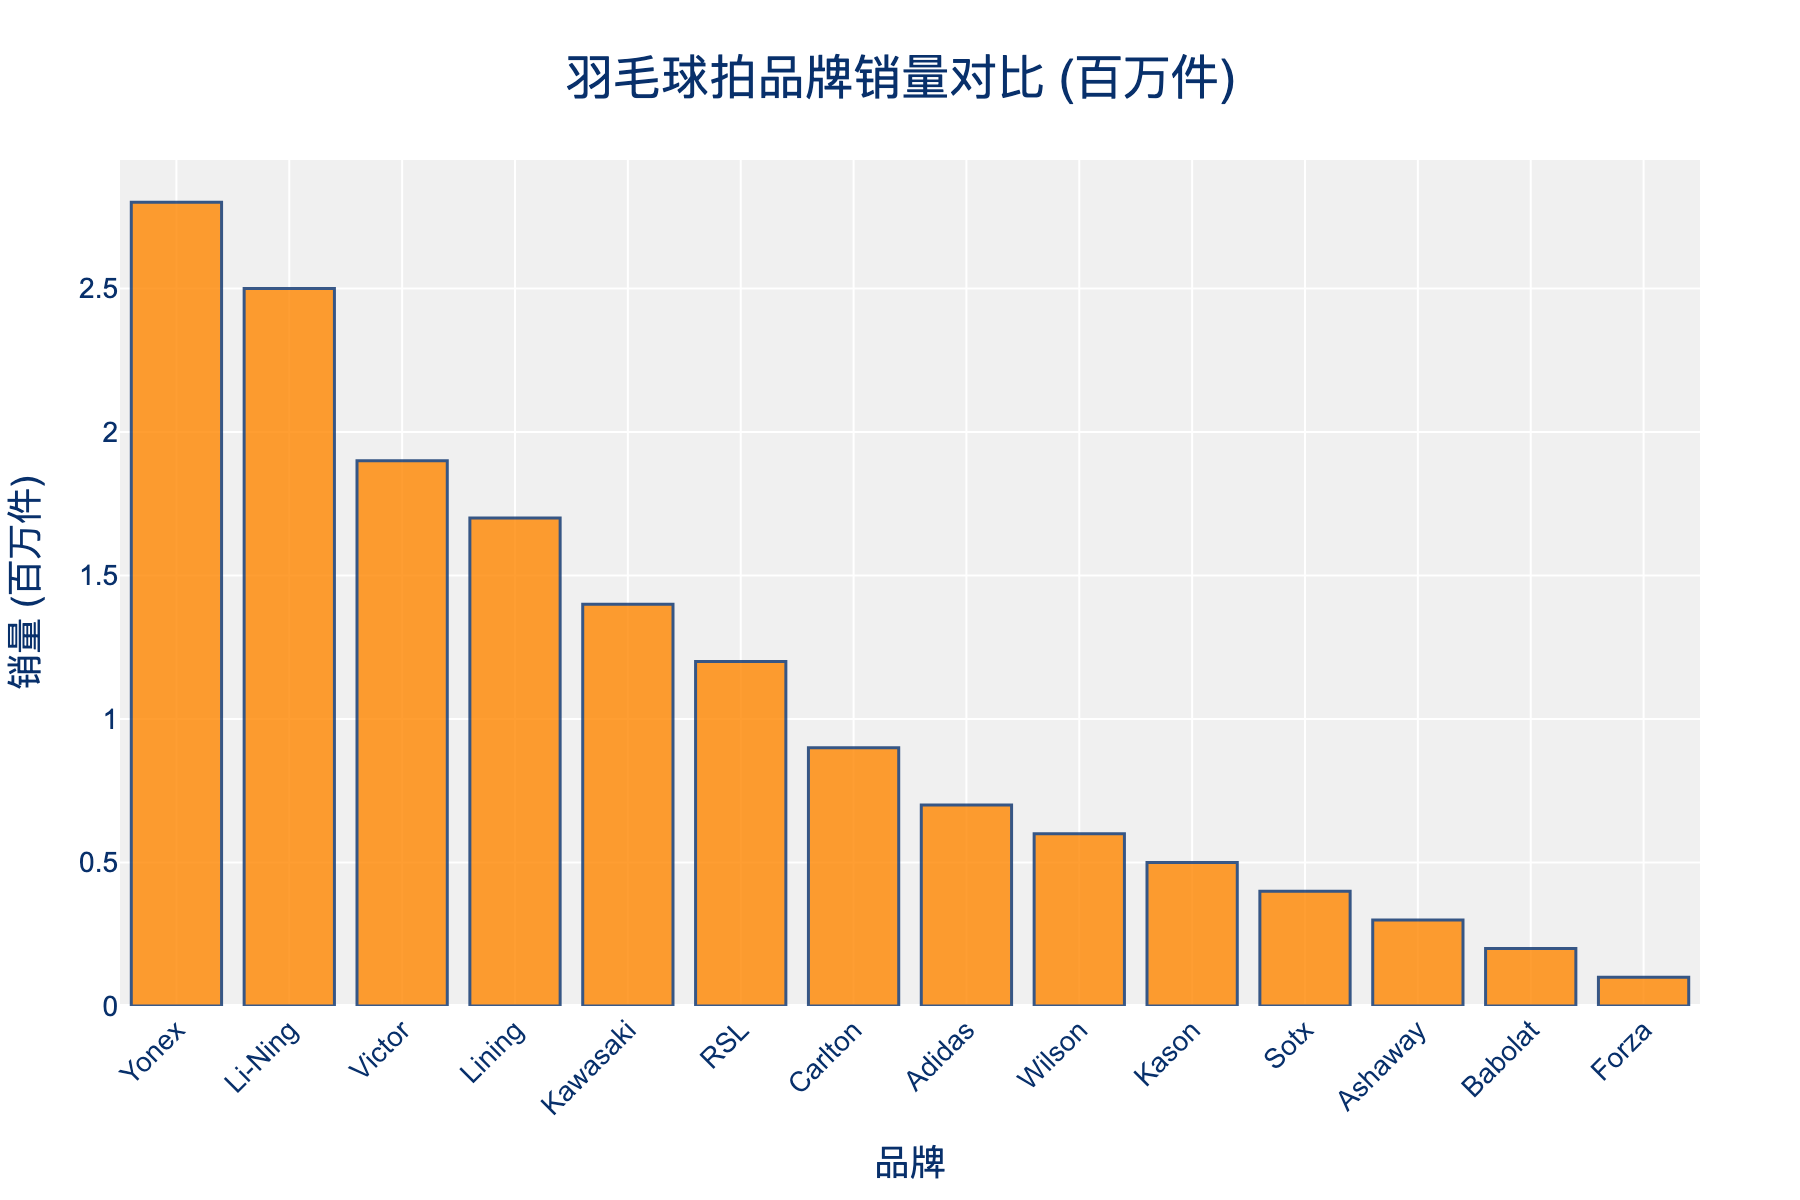Which brand has the highest badminton racket sales? The bar chart shows the highest bar belonging to the Yonex brand which indicates that Yonex has the highest sales.
Answer: Yonex Which are the top three brands in terms of sales? The three tallest bars in the chart are for the brands Yonex, Li-Ning, and Victor, representing the top three brands in terms of sales.
Answer: Yonex, Li-Ning, Victor How much more does Yonex sell compared to Wilson? According to the chart, Yonex sells 2.8 million units and Wilson sells 0.6 million units. Subtracting Wilson's sales from Yonex's sales: 2.8 - 0.6 = 2.2 million units.
Answer: 2.2 million units What is the combined sales volume of Kason, Sotx, Ashaway, and Babolat? Add the sales values for the four brands: Kason (0.5) + Sotx (0.4) + Ashaway (0.3) + Babolat (0.2) = 1.4 million units.
Answer: 1.4 million units What is the average sales among the top five brands? The top five brands by sales are Yonex (2.8), Li-Ning (2.5), Victor (1.9), Lining (1.7), and Kawasaki (1.4). The sum of their sales is 2.8 + 2.5 + 1.9 + 1.7 + 1.4 = 10.3. Divide this sum by 5 to get the average: 10.3 / 5 = 2.06 million units.
Answer: 2.06 million units How does Babolat's sales compare to Forza's sales? According to the chart, Babolat sells 0.2 million units, while Forza sells 0.1 million units. Babolat's sales are higher than Forza's sales.
Answer: Babolat has higher sales Which brands have sales lower than 1 million units? The brands with bars lower than 1 on the y-axis are Carlton (0.9), Adidas (0.7), Wilson (0.6), Kason (0.5), Sotx (0.4), Ashaway (0.3), Babolat (0.2), and Forza (0.1).
Answer: Carlton, Adidas, Wilson, Kason, Sotx, Ashaway, Babolat, Forza Which brand's sales are closest to 1.5 million units? Among all the brands, Lining has sales closest to 1.5 million units with 1.7 million units, which is the smallest difference from 1.5.
Answer: Lining What is the difference between the highest and lowest selling brands? The highest selling brand, Yonex, has sales of 2.8 million units, and the lowest selling brand, Forza, has 0.1 million units. The difference is 2.8 - 0.1 = 2.7 million units.
Answer: 2.7 million units 